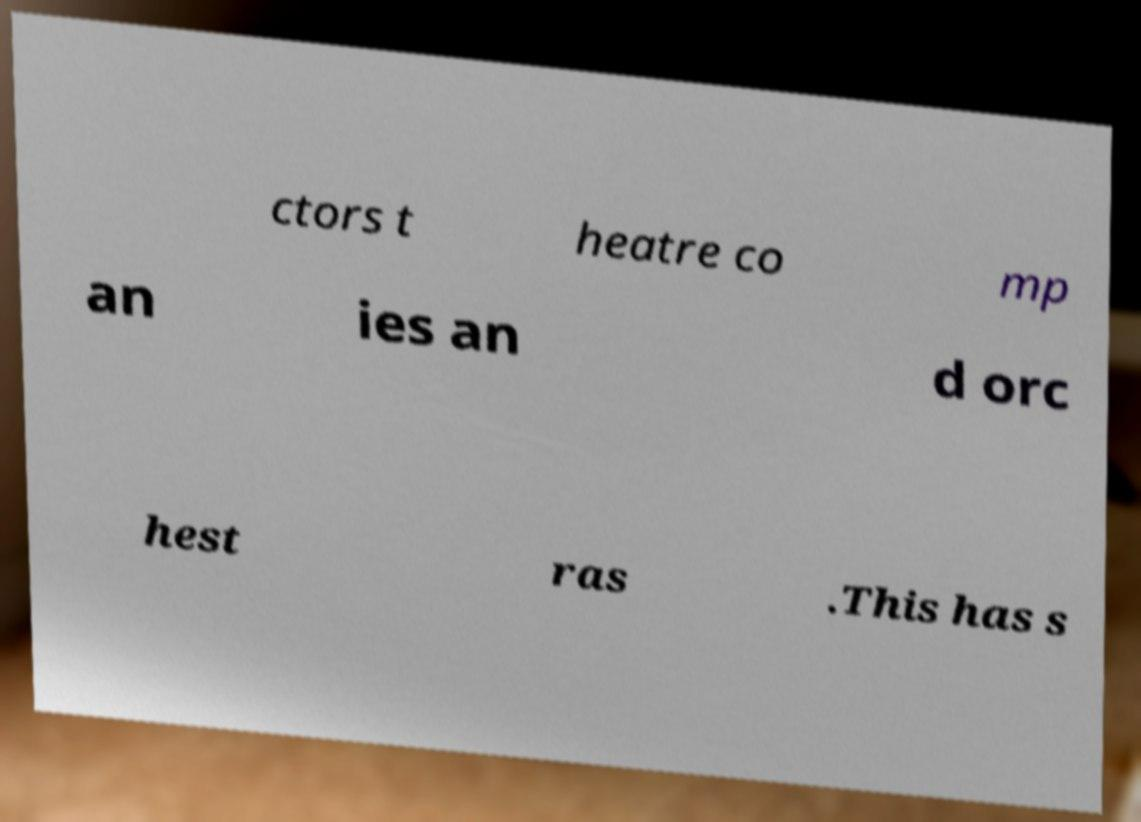Could you assist in decoding the text presented in this image and type it out clearly? ctors t heatre co mp an ies an d orc hest ras .This has s 